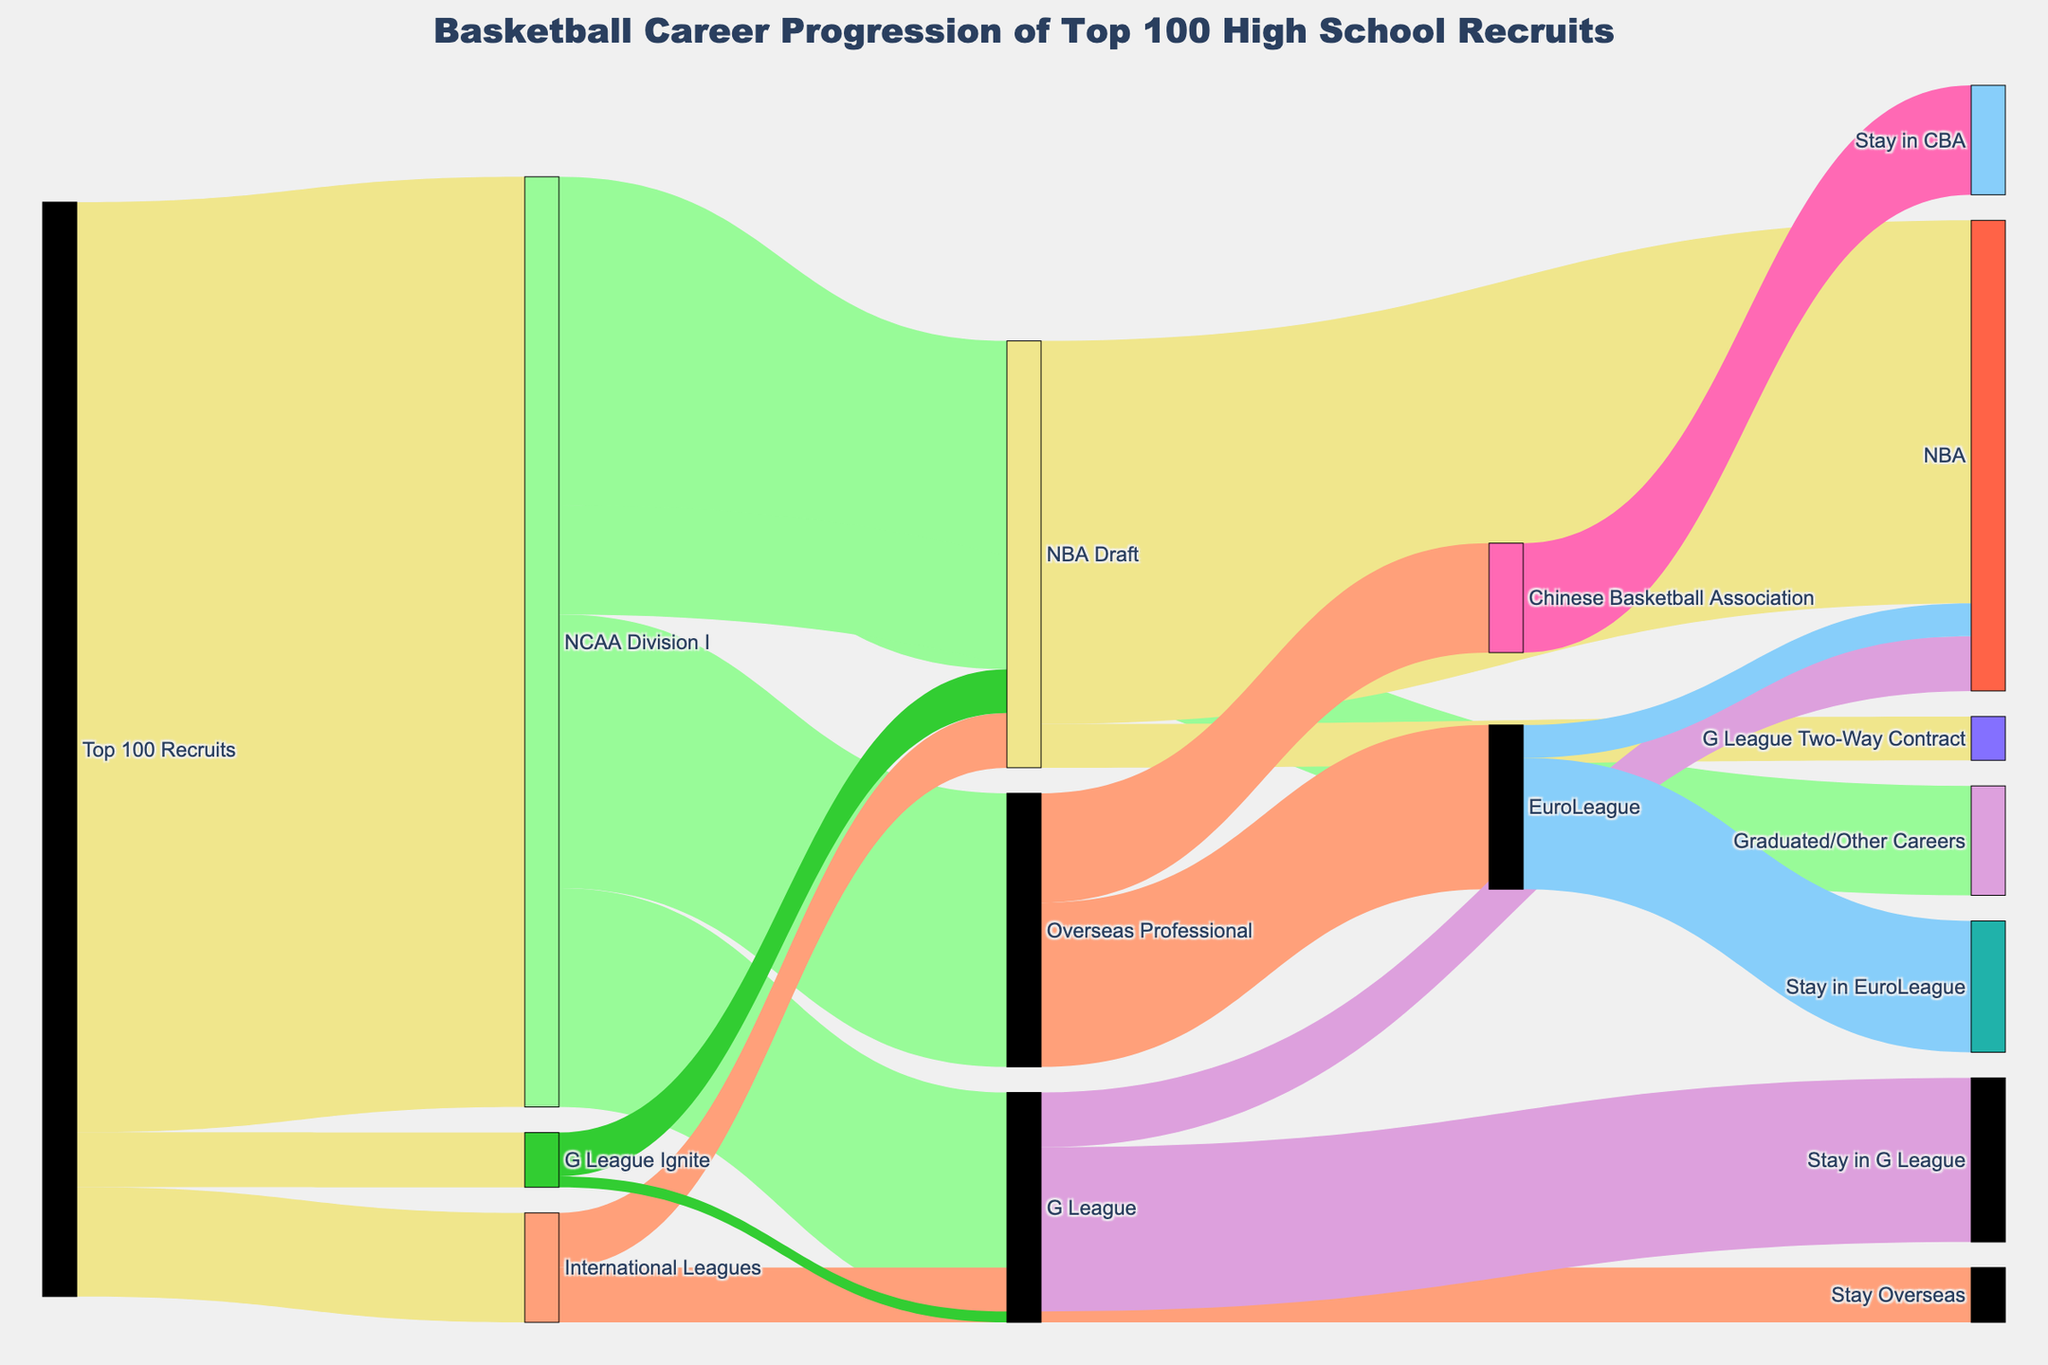Who are the groups shown in the initial node? The initial node labeled "Top 100 Recruits" has arrows pointing out towards three groups, indicating these are the primary categories where the top 100 high school recruits progress. These groups are labeled as "NCAA Division I," "International Leagues," and "G League Ignite."
Answer: NCAA Division I, International Leagues, G League Ignite What's the largest group among the Top 100 Recruits based on the diagram? From the diagram, the largest group that the top 100 recruits flow into is "NCAA Division I," which has the highest value of recruits (85).
Answer: NCAA Division I How many recruits from the NCAA Division I go into professional or semi-professional leagues? "NCAA Division I" flows into several destinations. To find those entering professional or semi-professional leagues, add: NBA Draft (30), Overseas Professional (25), and G League (20). 30 + 25 + 20 = 75
Answer: 75 What percentage of the recruits from NCAA Division I make it to the NBA Draft? To calculate this, divide the number of recruits who go to the NBA Draft (30) by the total number of recruits in NCAA Division I (85) and multiply by 100. (30/85) * 100 ≈ 35.3%
Answer: 35.3% Compare the numbers of recruits ending up in the G League from NCAA Division I to those who stay in the G League after joining from G League Ignite. From NCAA Division I, 20 recruits go to the G League. From G League Ignite, 1 recruit stays in the G League. Hence, 20 recruits from NCAA versus 1 from G League Ignite. 20 > 1.
Answer: 20 vs 1 How many recruits from International Leagues stay in those leagues? The diagram shows 5 recruits moving from International Leagues to "Stay Overseas", indicating they do not transition to another league.
Answer: 5 What's the flow from NBA Draft to the NBA and G League Two-Way Contract combined? The diagram shows 35 recruits flowing from NBA Draft to NBA, and 4 to the G League Two-Way Contract. 35 + 4 = 39
Answer: 39 Which destination has the highest number of players staying within from their professional league: EuroLeague or Chinese Basketball Association? The EuroLeague has 12 players staying, while the Chinese Basketball Association (CBA) has 10 players staying. 12 > 10
Answer: EuroLeague How many players move from Overseas Professional to leagues like EuroLeague and Chinese Basketball Association? Add the players moving from Overseas Professional to EuroLeague (15) and Chinese Basketball Association (10). 15 + 10 = 25
Answer: 25 What is the total number of recruits that go from the NCAA Division I into non-basketball professional careers? The diagram shows 10 recruits flowing from NCAA Division I to "Graduated/Other Careers", indicating they do not continue in basketball.
Answer: 10 